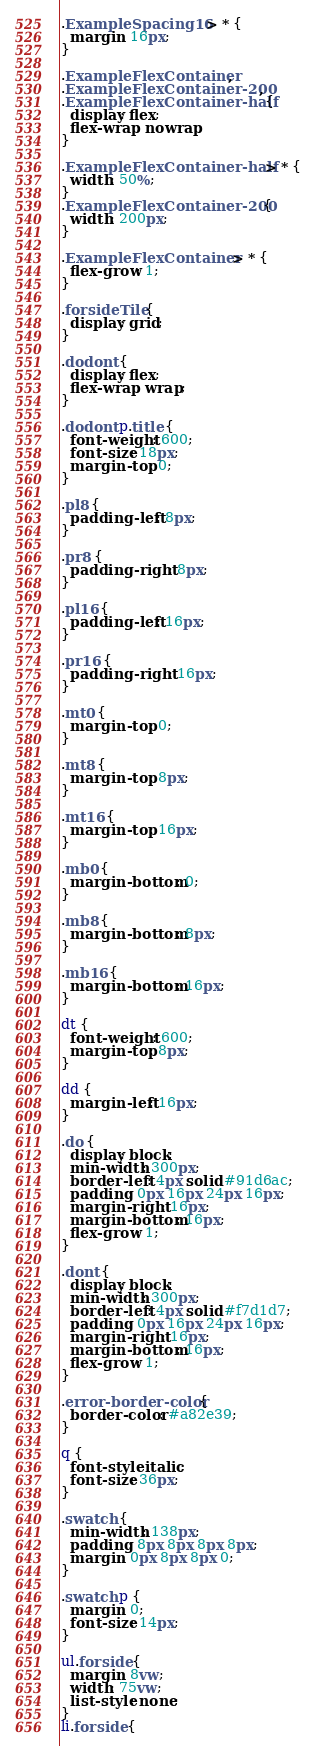Convert code to text. <code><loc_0><loc_0><loc_500><loc_500><_CSS_>
.ExampleSpacing16 > * {
  margin: 16px;
}

.ExampleFlexContainer,
.ExampleFlexContainer-200,
.ExampleFlexContainer-half {
  display: flex;
  flex-wrap: nowrap;
}

.ExampleFlexContainer-half > * {
  width: 50%;
}
.ExampleFlexContainer-200 {
  width: 200px;
}

.ExampleFlexContainer > * {
  flex-grow: 1;
}

.forsideTile {
  display: grid;
}

.dodont {
  display: flex;
  flex-wrap: wrap;
}

.dodont p.title {
  font-weight: 600;
  font-size: 18px;
  margin-top: 0;
}

.pl8 {
  padding-left: 8px;
}

.pr8 {
  padding-right: 8px;
}

.pl16 {
  padding-left: 16px;
}

.pr16 {
  padding-right: 16px;
}

.mt0 {
  margin-top: 0;
}

.mt8 {
  margin-top: 8px;
}

.mt16 {
  margin-top: 16px;
}

.mb0 {
  margin-bottom: 0;
}

.mb8 {
  margin-bottom: 8px;
}

.mb16 {
  margin-bottom: 16px;
}

dt {
  font-weight: 600;
  margin-top: 8px;
}

dd {
  margin-left: 16px;
}

.do {
  display: block;
  min-width: 300px;
  border-left: 4px solid #91d6ac;
  padding: 0px 16px 24px 16px;
  margin-right: 16px;
  margin-bottom: 16px;
  flex-grow: 1;
}

.dont {
  display: block;
  min-width: 300px;
  border-left: 4px solid #f7d1d7;
  padding: 0px 16px 24px 16px;
  margin-right: 16px;
  margin-bottom: 16px;
  flex-grow: 1;
}

.error-border-color {
  border-color: #a82e39;
}

q {
  font-style: italic;
  font-size: 36px;
}

.swatch {
  min-width: 138px;
  padding: 8px 8px 8px 8px;
  margin: 0px 8px 8px 0;
}

.swatch p {
  margin: 0;
  font-size: 14px;
}

ul.forside {
  margin: 8vw;
  width: 75vw;
  list-style: none;
}
li.forside {</code> 